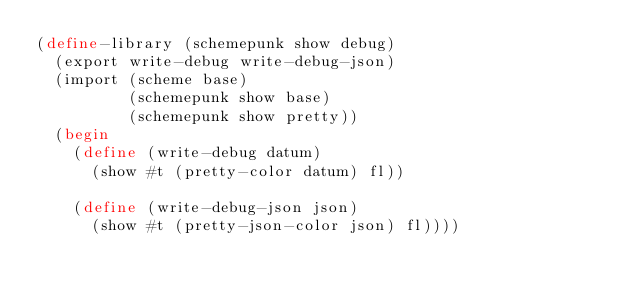Convert code to text. <code><loc_0><loc_0><loc_500><loc_500><_Scheme_>(define-library (schemepunk show debug)
  (export write-debug write-debug-json)
  (import (scheme base)
          (schemepunk show base)
          (schemepunk show pretty))
  (begin
    (define (write-debug datum)
      (show #t (pretty-color datum) fl))

    (define (write-debug-json json)
      (show #t (pretty-json-color json) fl))))
</code> 